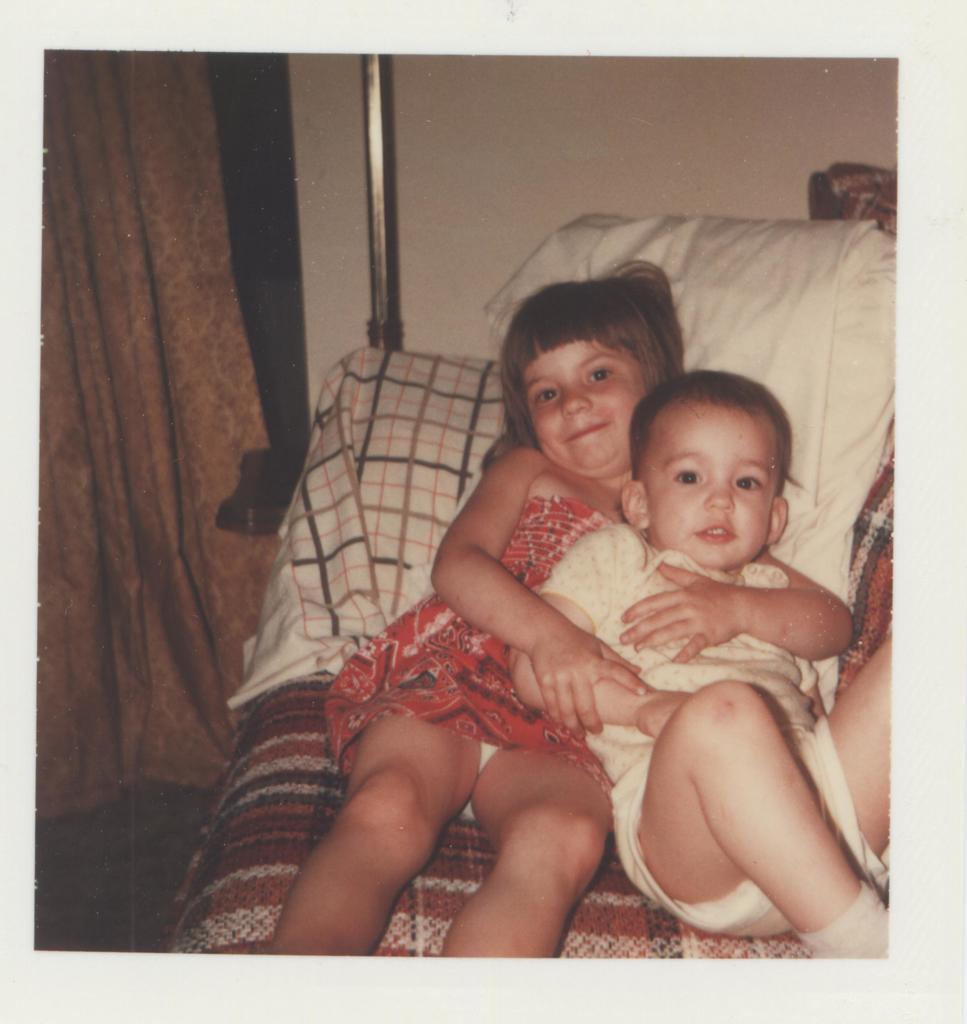Can you describe this image briefly? In this image we can see a boy and a girl holding each other lying on a bed. On the backside we can see a wall, pole and a curtain. 